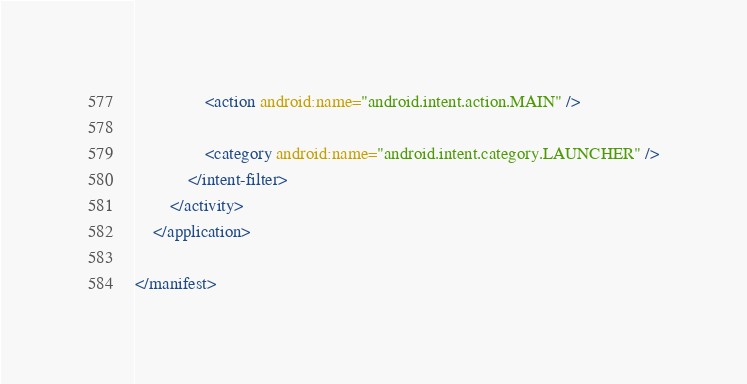Convert code to text. <code><loc_0><loc_0><loc_500><loc_500><_XML_>                <action android:name="android.intent.action.MAIN" />

                <category android:name="android.intent.category.LAUNCHER" />
            </intent-filter>
        </activity>
    </application>

</manifest></code> 